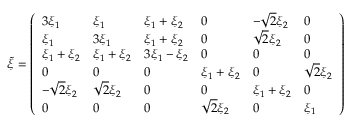Convert formula to latex. <formula><loc_0><loc_0><loc_500><loc_500>\tilde { \xi } = \left ( \begin{array} { l l l l l l } { 3 \xi _ { 1 } } & { \xi _ { 1 } } & { \xi _ { 1 } + \xi _ { 2 } } & { 0 } & { - \sqrt { 2 } \xi _ { 2 } } & { 0 } \\ { \xi _ { 1 } } & { 3 \xi _ { 1 } } & { \xi _ { 1 } + \xi _ { 2 } } & { 0 } & { \sqrt { 2 } \xi _ { 2 } } & { 0 } \\ { \xi _ { 1 } + \xi _ { 2 } } & { \xi _ { 1 } + \xi _ { 2 } } & { 3 \xi _ { 1 } - \xi _ { 2 } } & { 0 } & { 0 } & { 0 } \\ { 0 } & { 0 } & { 0 } & { \xi _ { 1 } + \xi _ { 2 } } & { 0 } & { \sqrt { 2 } \xi _ { 2 } } \\ { - \sqrt { 2 } \xi _ { 2 } } & { \sqrt { 2 } \xi _ { 2 } } & { 0 } & { 0 } & { \xi _ { 1 } + \xi _ { 2 } } & { 0 } \\ { 0 } & { 0 } & { 0 } & { \sqrt { 2 } \xi _ { 2 } } & { 0 } & { \xi _ { 1 } } \end{array} \right )</formula> 